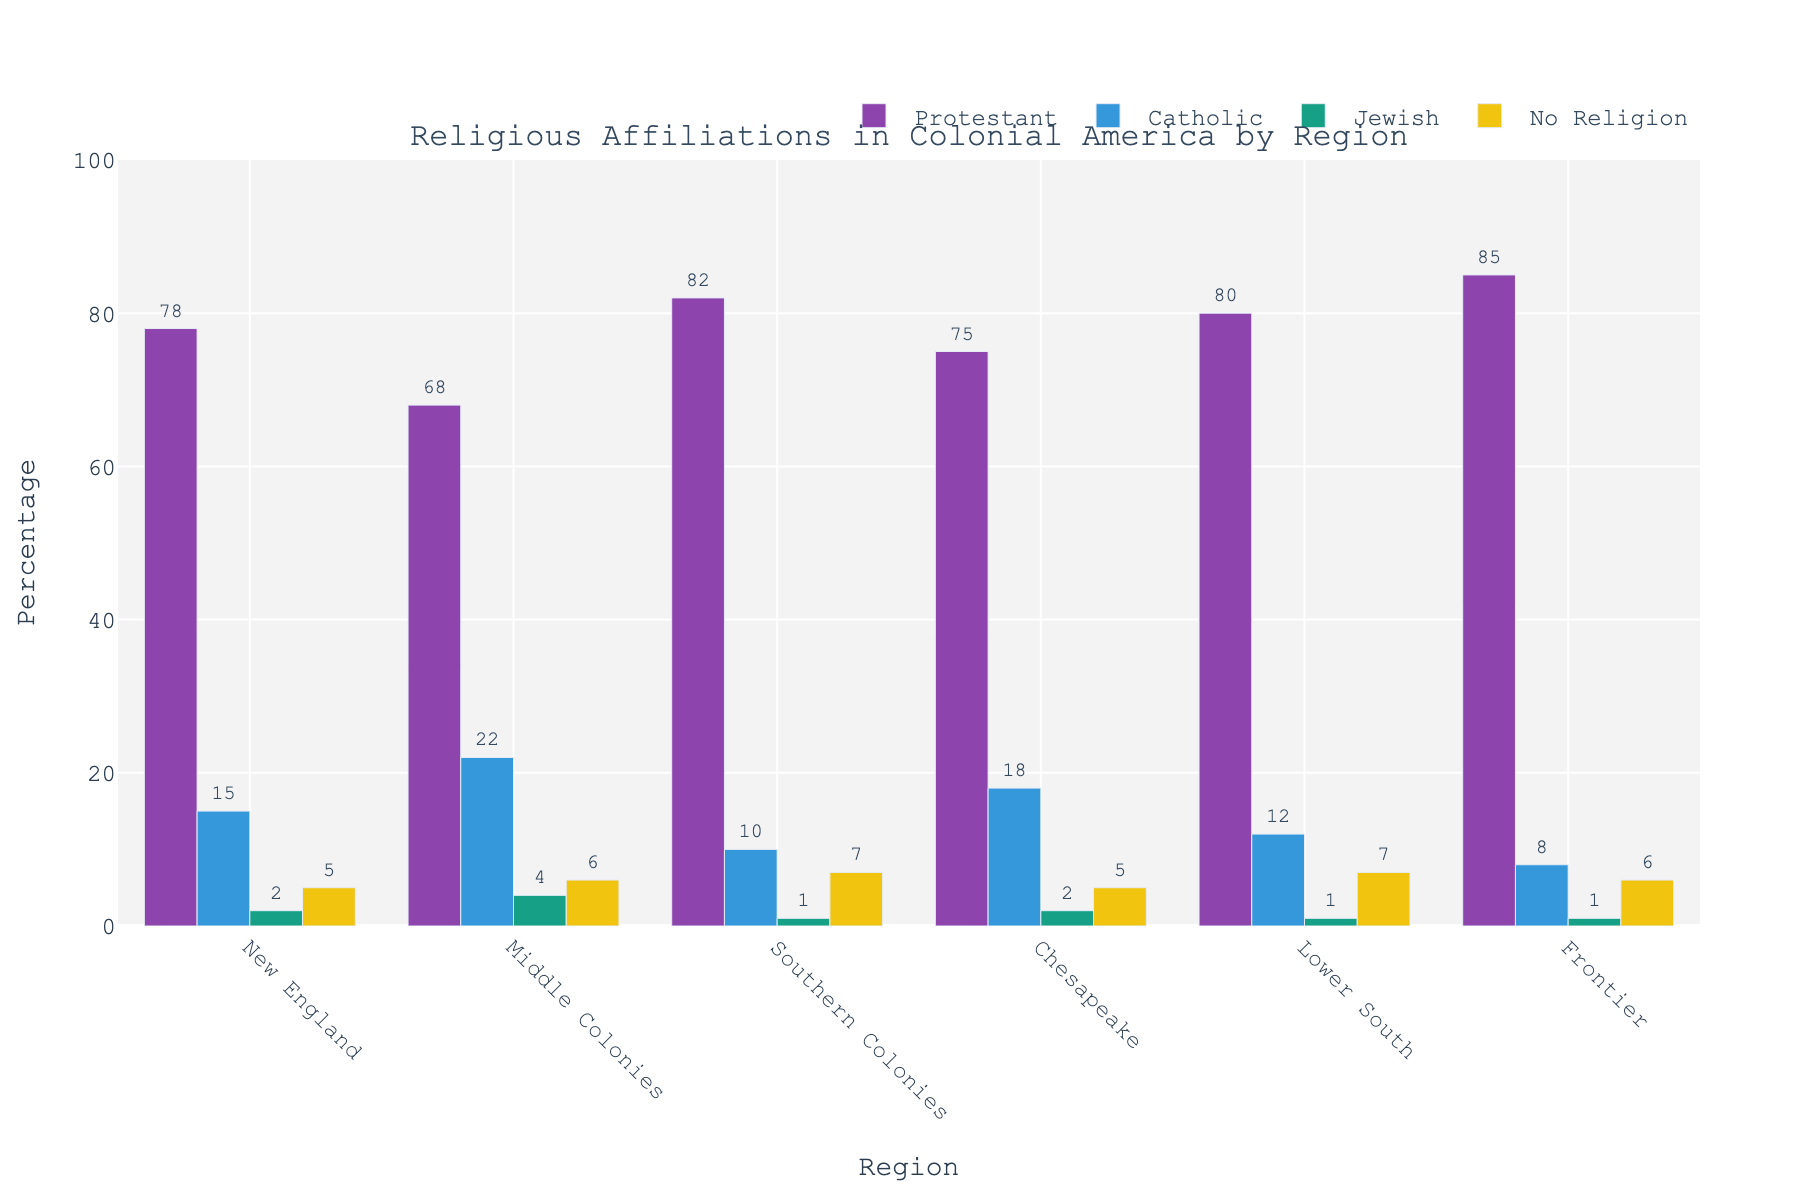Which region has the highest percentage of Protestants? To determine which region has the highest percentage of Protestants, we compare the heights of the bars representing Protestants across the different regions. The Frontier shows the highest percentage bar for Protestants, which is 85%.
Answer: Frontier Which region has the lowest percentage of Catholic population? By comparing the heights of the bars representing Catholics across all regions, we find that the Frontier has the shortest bar at 8%.
Answer: Frontier What is the total percentage of the Jewish population across all regions? To find the total percentage, we add the percentages of the Jewish population for each region: 2 (New England) + 4 (Middle Colonies) + 1 (Southern Colonies) + 2 (Chesapeake) + 1 (Lower South) + 1 (Frontier) = 11%.
Answer: 11% Which religious affiliation is most common in the Southern Colonies and by what percentage? In the Southern Colonies, the highest bar corresponds to Protestants at 82%.
Answer: Protestant, 82% How do the percentages of people with no religion compare between the Chesapeake and the Lower South? Both the Chesapeake and Lower South have the exact same percentage of people with no religion, which is 7%.
Answer: Equal, 7% What is the average percentage of Catholics across all regions? To find the average percentage of Catholics, add the percentages from each region and divide by the number of regions: (15 + 22 + 10 + 18 + 12 + 8) / 6 = 85 / 6 ≈ 14.17%.
Answer: 14.17% What is the difference in the percentage of Protestants between the New England and the Middle Colonies? By subtracting the percentage of Protestants in the Middle Colonies from that in New England: 78 - 68 = 10%.
Answer: 10% Which region has the most balanced distribution of religious affiliations? To determine the balance, we observe the relative heights of all bars for each region. The Middle Colonies have bars for Protestants, Catholics, Jewish, and No Religion that are more evenly distributed compared to other regions.
Answer: Middle Colonies What is the combined percentage of Protestants and Catholics in the Chesapeake region? To find the combined percentage, add the percentages of Protestants and Catholics in the Chesapeake: 75% (Protestants) + 18% (Catholics) = 93%.
Answer: 93% In which region is the percentage of the Jewish population more than double of the percentage in the Lower South? To find this, we need to check each region's Jewish population percentage and compare it to twice the Lower South's percentage (2 * 1% = 2%). The Jewish populations more than double are Middle Colonies (4%) and New England (2%).
Answer: Middle Colonies 